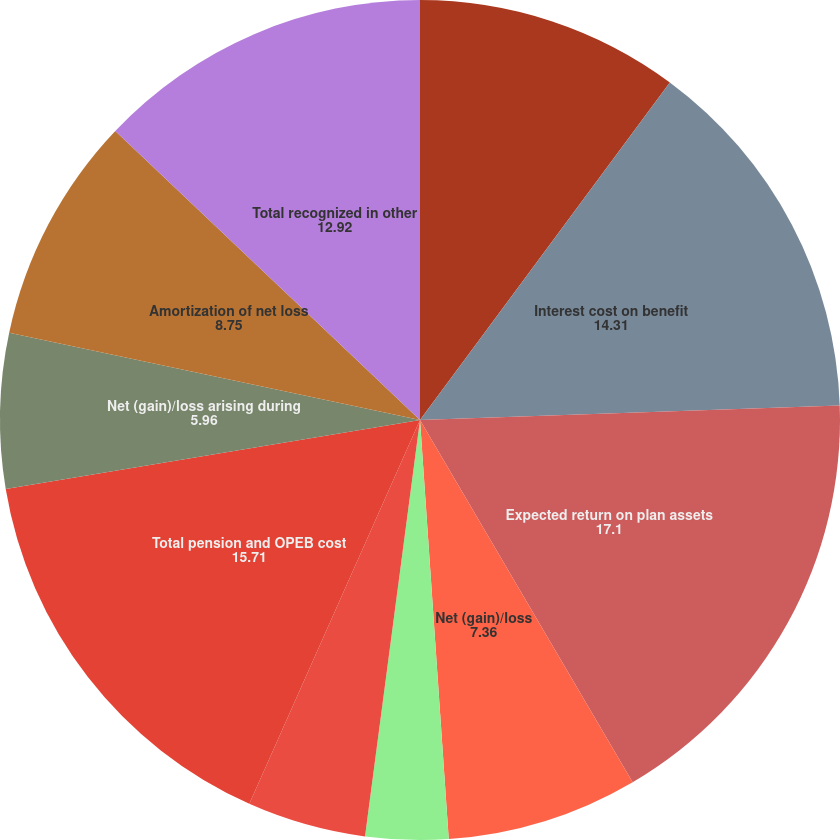Convert chart to OTSL. <chart><loc_0><loc_0><loc_500><loc_500><pie_chart><fcel>Benefits earned during the<fcel>Interest cost on benefit<fcel>Expected return on plan assets<fcel>Net (gain)/loss<fcel>Net periodic defined benefit<fcel>Total defined benefit plans<fcel>Total pension and OPEB cost<fcel>Net (gain)/loss arising during<fcel>Amortization of net loss<fcel>Total recognized in other<nl><fcel>10.14%<fcel>14.31%<fcel>17.1%<fcel>7.36%<fcel>3.18%<fcel>4.57%<fcel>15.71%<fcel>5.96%<fcel>8.75%<fcel>12.92%<nl></chart> 